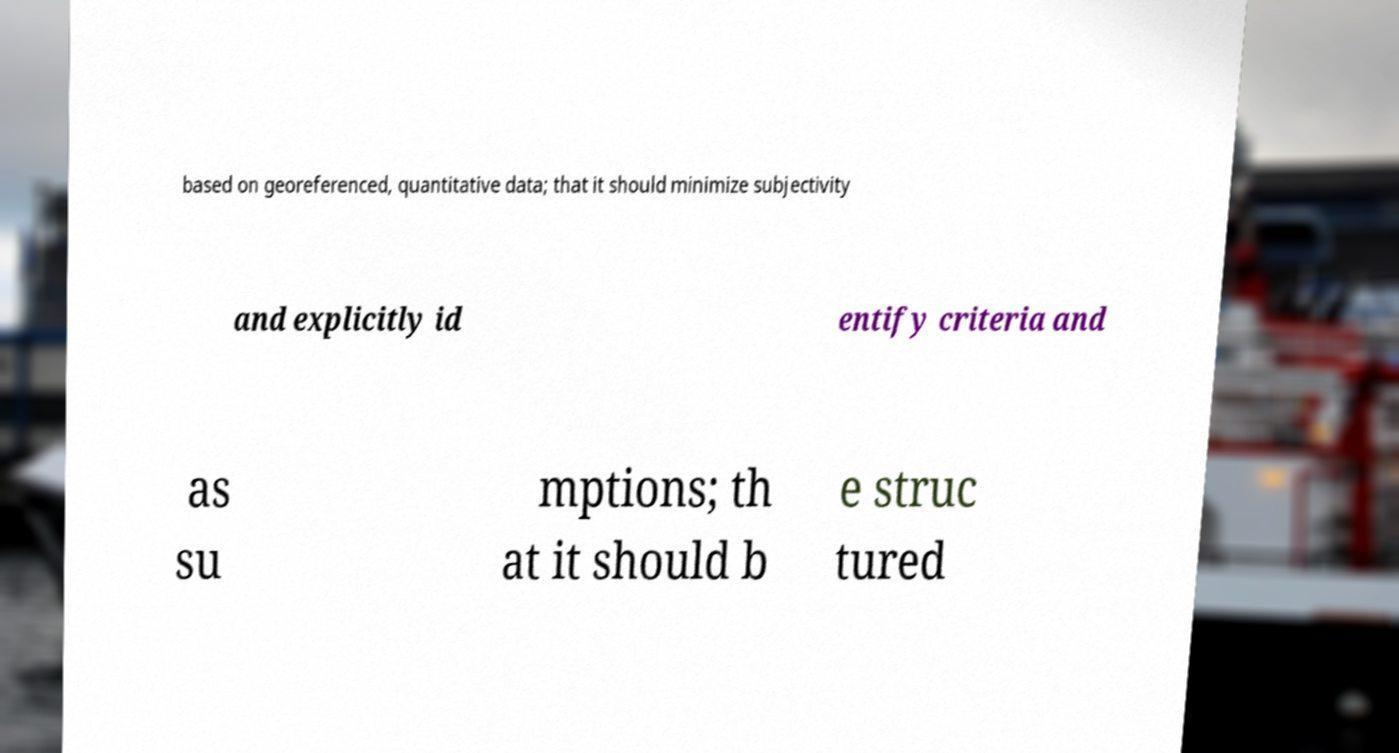There's text embedded in this image that I need extracted. Can you transcribe it verbatim? based on georeferenced, quantitative data; that it should minimize subjectivity and explicitly id entify criteria and as su mptions; th at it should b e struc tured 